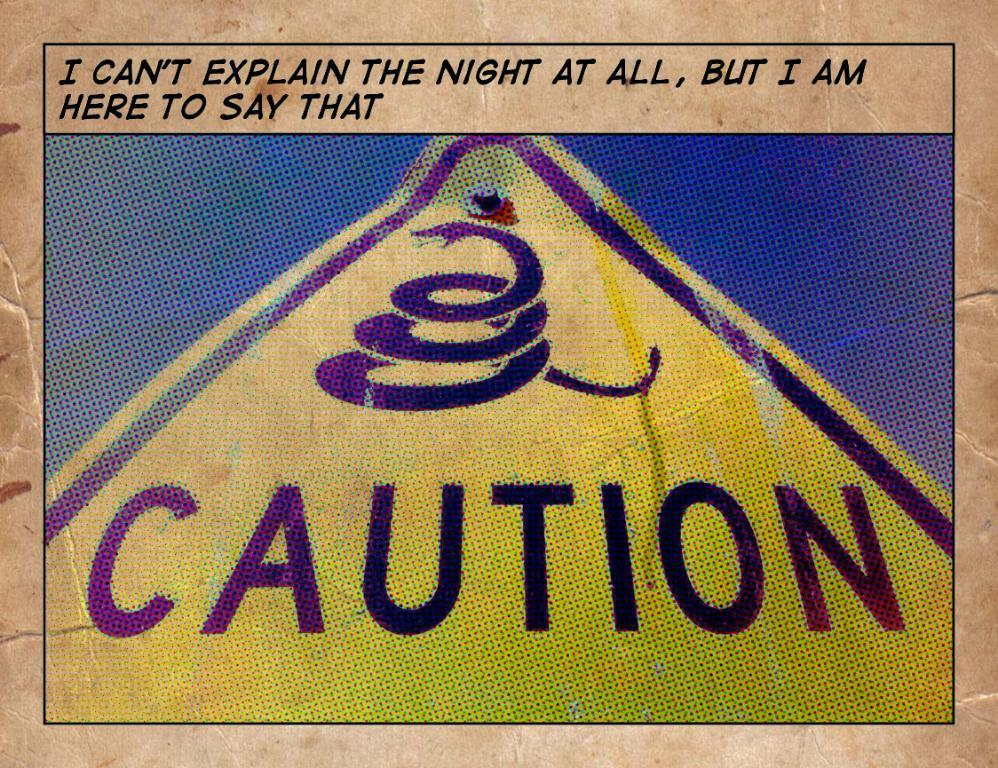Provide a one-sentence caption for the provided image. a yellow caution triangle sign with snake logo. 